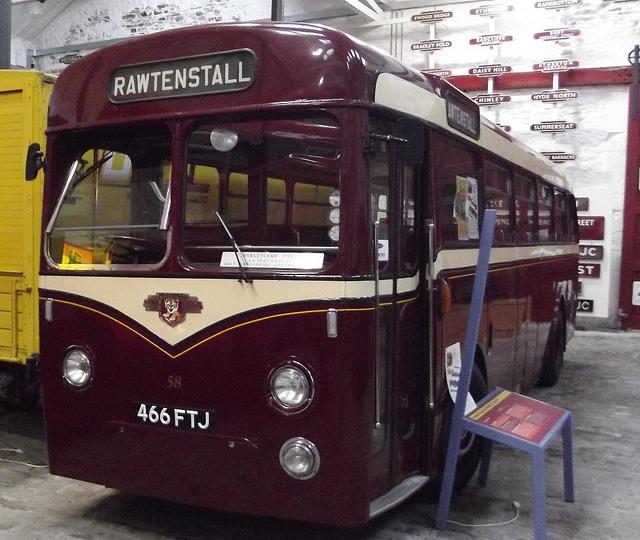What word is displayed at the top of the bus?
Write a very short answer. Rawtenstall. Is the bus parked indoors or outdoors?
Be succinct. Indoors. Is the bus moving?
Keep it brief. No. 